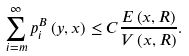Convert formula to latex. <formula><loc_0><loc_0><loc_500><loc_500>\sum _ { i = m } ^ { \infty } p _ { i } ^ { B } \left ( y , x \right ) \leq C \frac { E \left ( x , R \right ) } { V \left ( x , R \right ) } .</formula> 